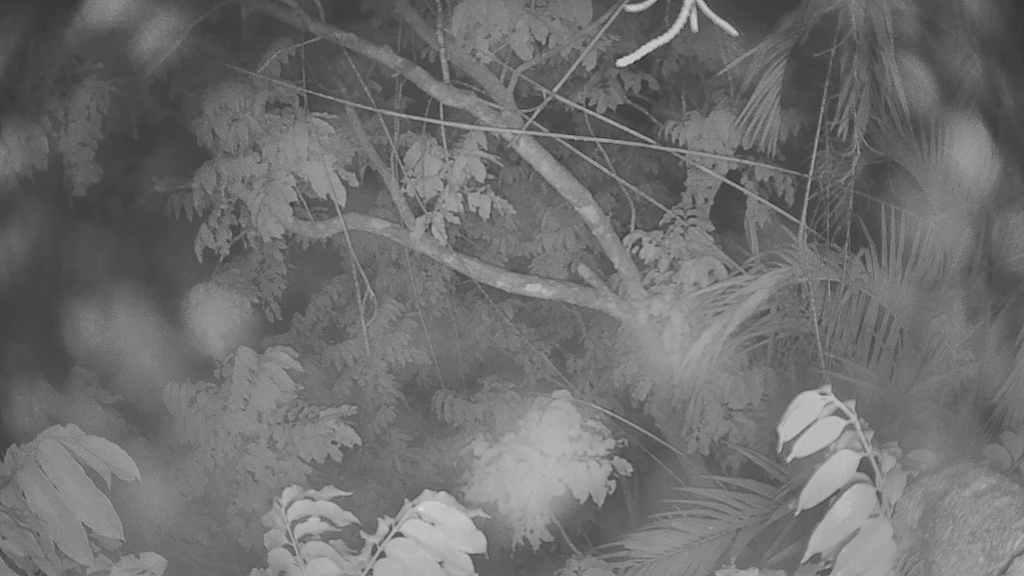What is the color scheme of the image? The image is black and white. What type of natural elements can be seen in the image? There are trees in the image. Are there any areas of the image that are not clear or sharp? Some parts of the image appear blurred. What type of carriage is being pulled by the horse in the image? There is no horse or carriage present in the image; it only features trees and a black and white color scheme. What type of science experiment is being conducted in the image? There is no science experiment or any indication of scientific activity in the image. 